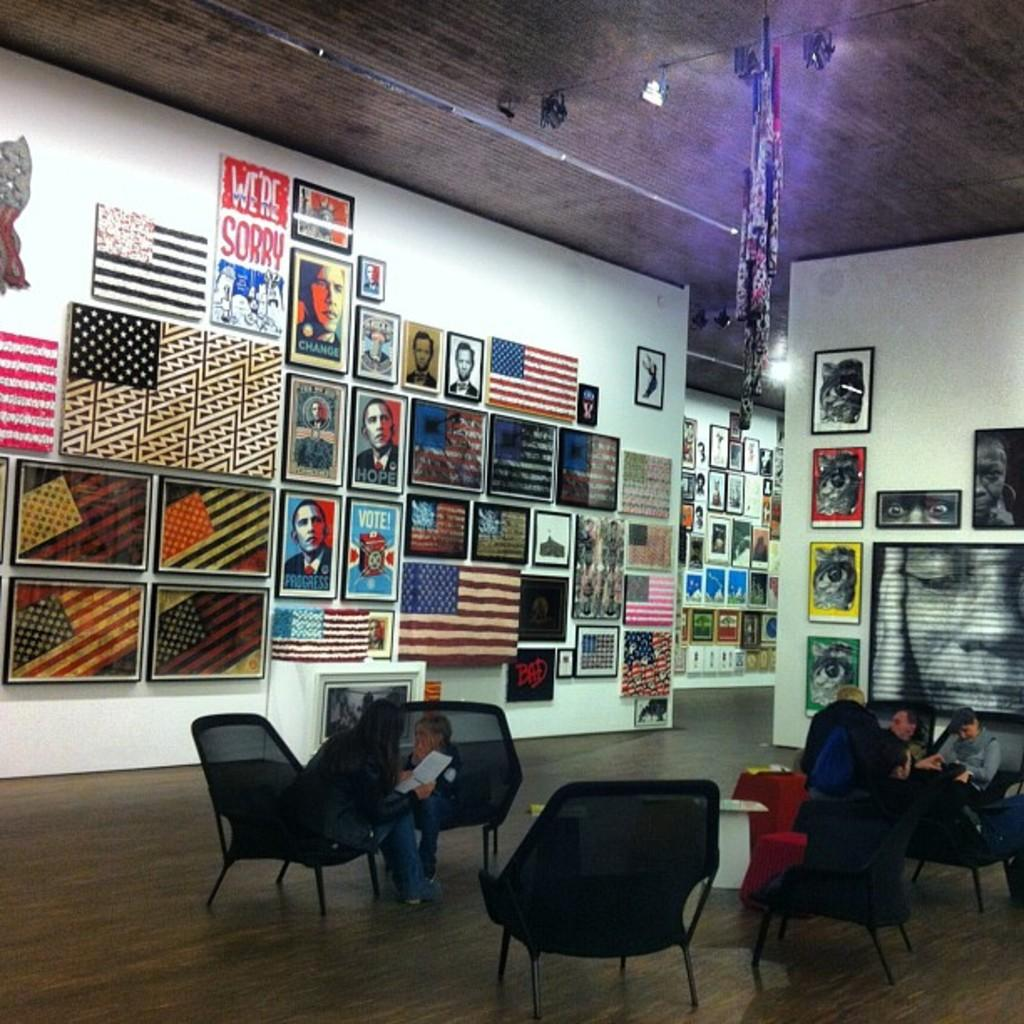Who or what is present in the image? There are people in the image. What are the people doing in the image? The people are sitting on chairs. What can be seen on the wall in the image? There are frames on the wall. How does the dust settle on the cap in the image? There is no dust or cap present in the image. What type of cap is being worn by the people in the image? There is no cap visible in the image, as the people are sitting on chairs and not wearing any headgear. 